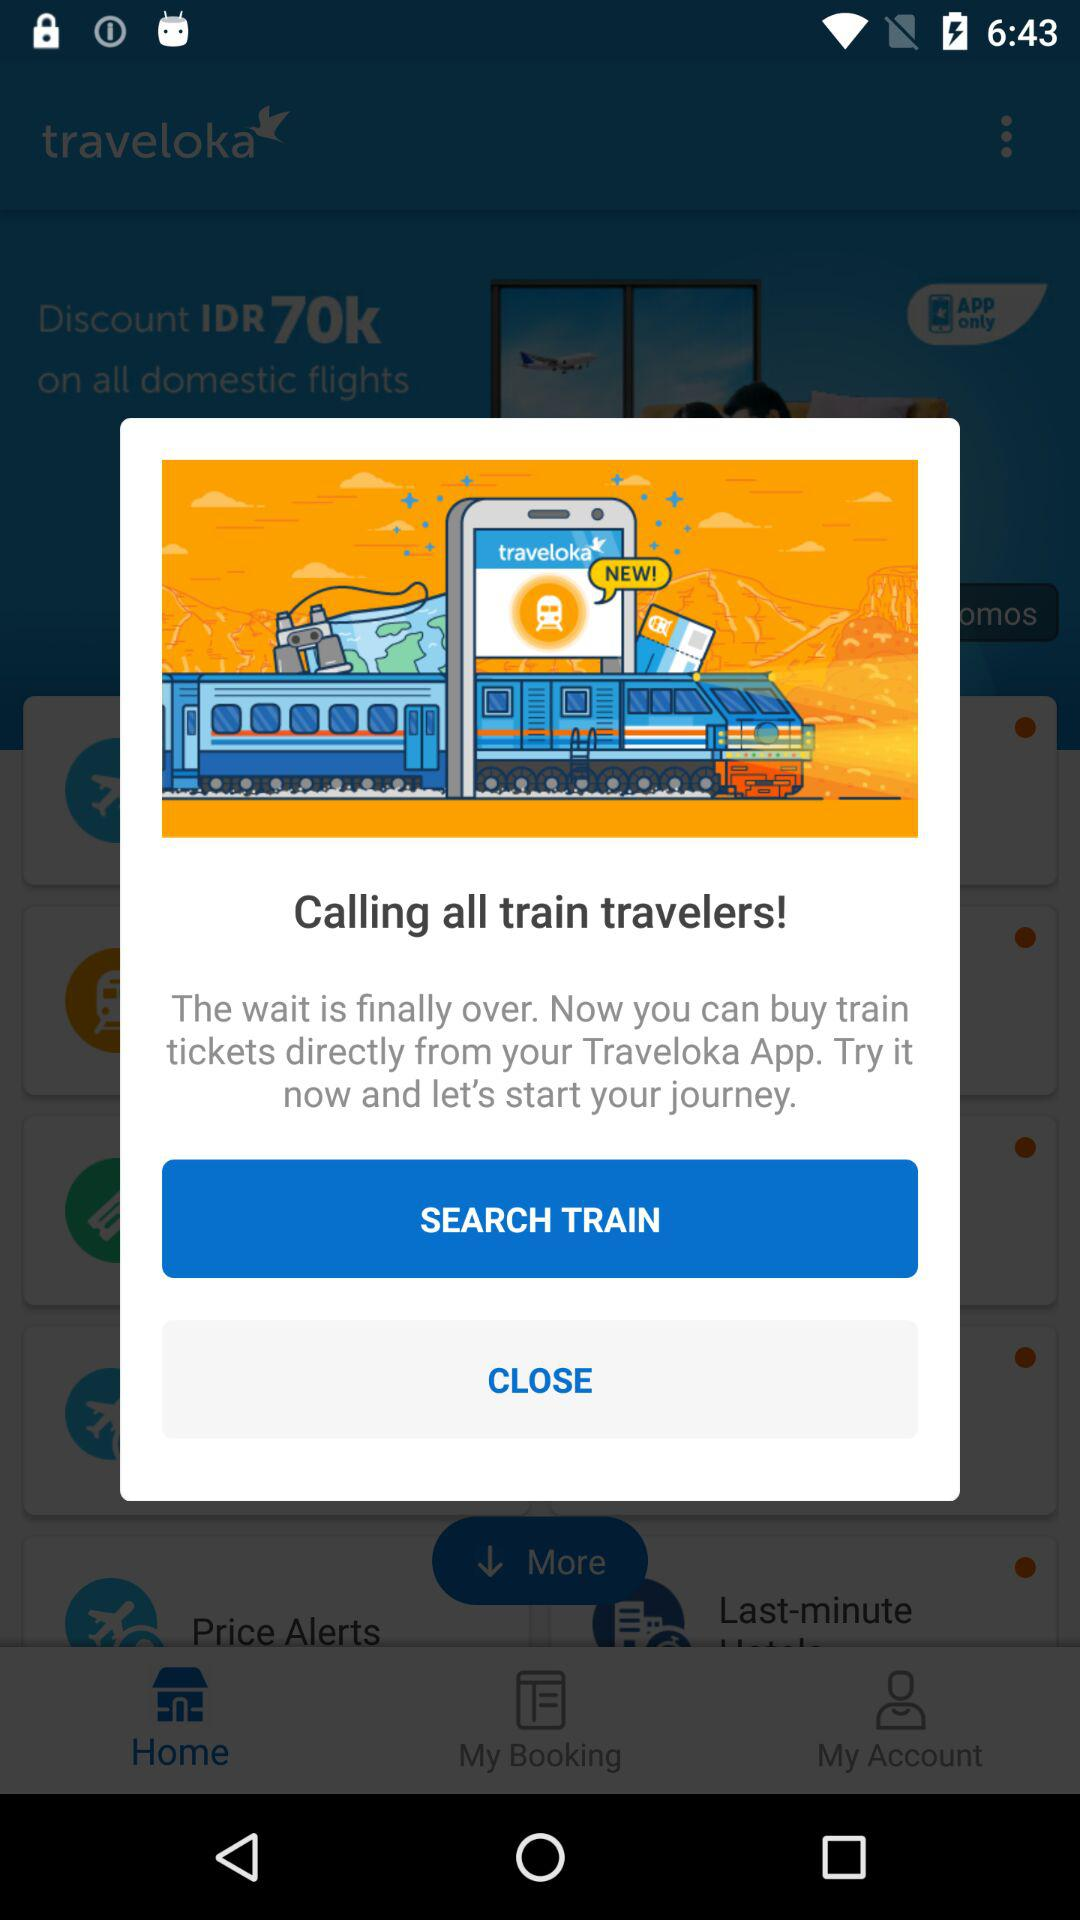What is the name of the application? The name of the application is "traveloka". 